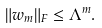<formula> <loc_0><loc_0><loc_500><loc_500>\| w _ { m } \| _ { F } \leq \Lambda ^ { m } .</formula> 